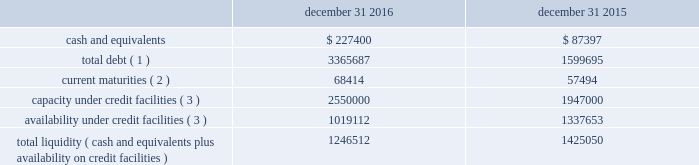Liquidity and capital resources the table summarizes liquidity data as of the dates indicated ( in thousands ) : december 31 , december 31 .
Total debt ( 1 ) 3365687 1599695 current maturities ( 2 ) 68414 57494 capacity under credit facilities ( 3 ) 2550000 1947000 availability under credit facilities ( 3 ) 1019112 1337653 total liquidity ( cash and equivalents plus availability on credit facilities ) 1246512 1425050 ( 1 ) debt amounts reflect the gross values to be repaid ( excluding debt issuance costs of $ 23.9 million and $ 15.0 million as of december 31 , 2016 and 2015 , respectively ) .
( 2 ) debt amounts reflect the gross values to be repaid ( excluding debt issuance costs of $ 2.3 million and $ 1.5 million as of december 31 , 2016 and 2015 , respectively ) .
( 3 ) includes our revolving credit facilities , our receivables securitization facility , and letters of credit .
We assess our liquidity in terms of our ability to fund our operations and provide for expansion through both internal development and acquisitions .
Our primary sources of liquidity are cash flows from operations and our credit facilities .
We utilize our cash flows from operations to fund working capital and capital expenditures , with the excess amounts going towards funding acquisitions or paying down outstanding debt .
As we have pursued acquisitions as part of our growth strategy , our cash flows from operations have not always been sufficient to cover our investing activities .
To fund our acquisitions , we have accessed various forms of debt financing , including revolving credit facilities , senior notes , and a receivables securitization facility .
As of december 31 , 2016 , we had debt outstanding and additional available sources of financing , as follows : 2022 senior secured credit facilities maturing in january 2021 , composed of term loans totaling $ 750 million ( $ 732.7 million outstanding at december 31 , 2016 ) and $ 2.45 billion in revolving credit ( $ 1.36 billion outstanding at december 31 , 2016 ) , bearing interest at variable rates ( although a portion of this debt is hedged through interest rate swap contracts ) reduced by $ 72.7 million of amounts outstanding under letters of credit 2022 senior notes totaling $ 600 million , maturing in may 2023 and bearing interest at a 4.75% ( 4.75 % ) fixed rate 2022 euro notes totaling $ 526 million ( 20ac500 million ) , maturing in april 2024 and bearing interest at a 3.875% ( 3.875 % ) fixed rate 2022 receivables securitization facility with availability up to $ 100 million ( $ 100 million outstanding as of december 31 , 2016 ) , maturing in november 2019 and bearing interest at variable commercial paper from time to time , we may undertake financing transactions to increase our available liquidity , such as our january 2016 amendment to our senior secured credit facilities , the issuance of 20ac500 million of euro notes in april 2016 , and the november 2016 amendment to our receivables securitization facility .
The rhiag acquisition was the catalyst for the april issuance of 20ac500 million of euro notes .
Given that rhiag is a long term asset , we considered alternative financing options and decided to fund a portion of this acquisition through the issuance of long term notes .
Additionally , the interest rates on rhiag's acquired debt ranged between 6.45% ( 6.45 % ) and 7.25% ( 7.25 % ) .
With the issuance of the 20ac500 million of senior notes at a rate of 3.875% ( 3.875 % ) , we were able to replace rhiag's borrowings with long term financing at favorable rates .
This refinancing also provides financial flexibility to execute our long-term growth strategy by freeing up availability under our revolver .
If we see an attractive acquisition opportunity , we have the ability to use our revolver to move quickly and have certainty of funding .
As of december 31 , 2016 , we had approximately $ 1.02 billion available under our credit facilities .
Combined with approximately $ 227.4 million of cash and equivalents at december 31 , 2016 , we had approximately $ 1.25 billion in available liquidity , a decrease of $ 178.5 million from our available liquidity as of december 31 , 2015 .
We expect to use the proceeds from the sale of pgw's glass manufacturing business to pay down borrowings under our revolving credit facilities , which would increase our available liquidity by approximately $ 310 million when the transaction closes. .
What was the change in total debt from 2015 to 2016? 
Computations: (3365687 - 1599695)
Answer: 1765992.0. Liquidity and capital resources the table summarizes liquidity data as of the dates indicated ( in thousands ) : december 31 , december 31 .
Total debt ( 1 ) 3365687 1599695 current maturities ( 2 ) 68414 57494 capacity under credit facilities ( 3 ) 2550000 1947000 availability under credit facilities ( 3 ) 1019112 1337653 total liquidity ( cash and equivalents plus availability on credit facilities ) 1246512 1425050 ( 1 ) debt amounts reflect the gross values to be repaid ( excluding debt issuance costs of $ 23.9 million and $ 15.0 million as of december 31 , 2016 and 2015 , respectively ) .
( 2 ) debt amounts reflect the gross values to be repaid ( excluding debt issuance costs of $ 2.3 million and $ 1.5 million as of december 31 , 2016 and 2015 , respectively ) .
( 3 ) includes our revolving credit facilities , our receivables securitization facility , and letters of credit .
We assess our liquidity in terms of our ability to fund our operations and provide for expansion through both internal development and acquisitions .
Our primary sources of liquidity are cash flows from operations and our credit facilities .
We utilize our cash flows from operations to fund working capital and capital expenditures , with the excess amounts going towards funding acquisitions or paying down outstanding debt .
As we have pursued acquisitions as part of our growth strategy , our cash flows from operations have not always been sufficient to cover our investing activities .
To fund our acquisitions , we have accessed various forms of debt financing , including revolving credit facilities , senior notes , and a receivables securitization facility .
As of december 31 , 2016 , we had debt outstanding and additional available sources of financing , as follows : 2022 senior secured credit facilities maturing in january 2021 , composed of term loans totaling $ 750 million ( $ 732.7 million outstanding at december 31 , 2016 ) and $ 2.45 billion in revolving credit ( $ 1.36 billion outstanding at december 31 , 2016 ) , bearing interest at variable rates ( although a portion of this debt is hedged through interest rate swap contracts ) reduced by $ 72.7 million of amounts outstanding under letters of credit 2022 senior notes totaling $ 600 million , maturing in may 2023 and bearing interest at a 4.75% ( 4.75 % ) fixed rate 2022 euro notes totaling $ 526 million ( 20ac500 million ) , maturing in april 2024 and bearing interest at a 3.875% ( 3.875 % ) fixed rate 2022 receivables securitization facility with availability up to $ 100 million ( $ 100 million outstanding as of december 31 , 2016 ) , maturing in november 2019 and bearing interest at variable commercial paper from time to time , we may undertake financing transactions to increase our available liquidity , such as our january 2016 amendment to our senior secured credit facilities , the issuance of 20ac500 million of euro notes in april 2016 , and the november 2016 amendment to our receivables securitization facility .
The rhiag acquisition was the catalyst for the april issuance of 20ac500 million of euro notes .
Given that rhiag is a long term asset , we considered alternative financing options and decided to fund a portion of this acquisition through the issuance of long term notes .
Additionally , the interest rates on rhiag's acquired debt ranged between 6.45% ( 6.45 % ) and 7.25% ( 7.25 % ) .
With the issuance of the 20ac500 million of senior notes at a rate of 3.875% ( 3.875 % ) , we were able to replace rhiag's borrowings with long term financing at favorable rates .
This refinancing also provides financial flexibility to execute our long-term growth strategy by freeing up availability under our revolver .
If we see an attractive acquisition opportunity , we have the ability to use our revolver to move quickly and have certainty of funding .
As of december 31 , 2016 , we had approximately $ 1.02 billion available under our credit facilities .
Combined with approximately $ 227.4 million of cash and equivalents at december 31 , 2016 , we had approximately $ 1.25 billion in available liquidity , a decrease of $ 178.5 million from our available liquidity as of december 31 , 2015 .
We expect to use the proceeds from the sale of pgw's glass manufacturing business to pay down borrowings under our revolving credit facilities , which would increase our available liquidity by approximately $ 310 million when the transaction closes. .
What was the percentage decline in the liquidity in 2016 from 2015? 
Computations: (178.5 / (1.25 + 178.5))
Answer: 0.99305. 